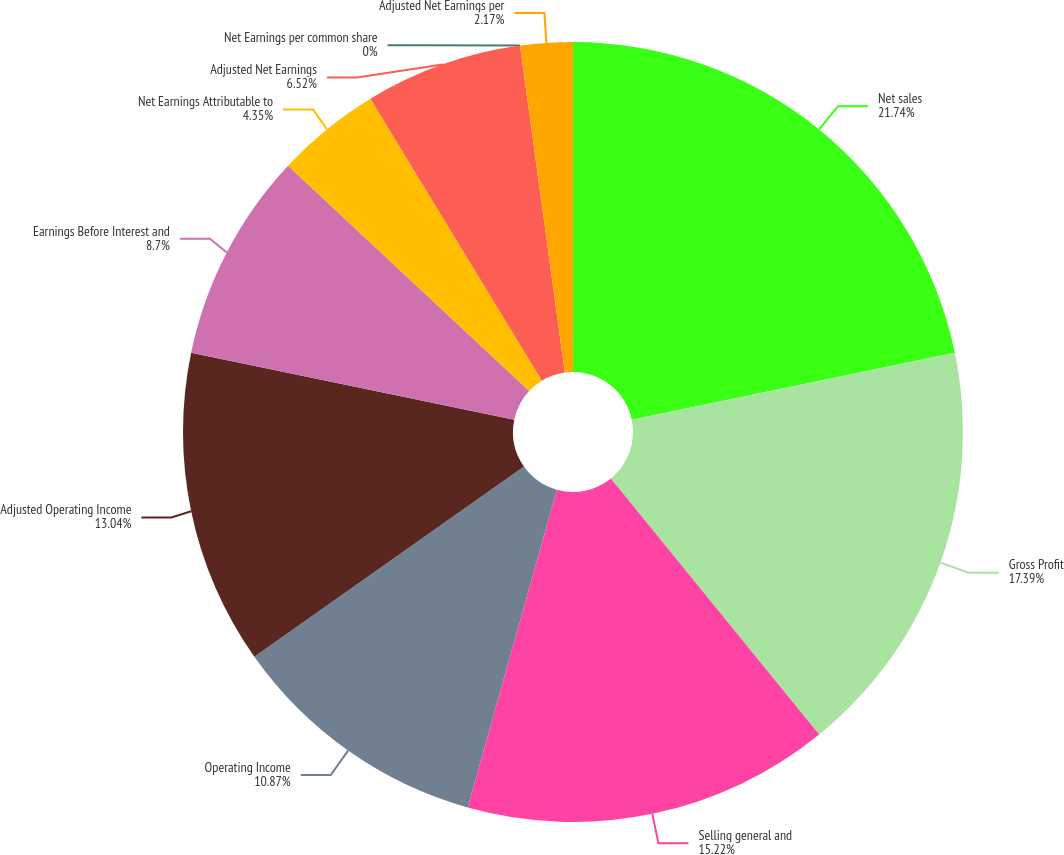<chart> <loc_0><loc_0><loc_500><loc_500><pie_chart><fcel>Net sales<fcel>Gross Profit<fcel>Selling general and<fcel>Operating Income<fcel>Adjusted Operating Income<fcel>Earnings Before Interest and<fcel>Net Earnings Attributable to<fcel>Adjusted Net Earnings<fcel>Net Earnings per common share<fcel>Adjusted Net Earnings per<nl><fcel>21.74%<fcel>17.39%<fcel>15.22%<fcel>10.87%<fcel>13.04%<fcel>8.7%<fcel>4.35%<fcel>6.52%<fcel>0.0%<fcel>2.17%<nl></chart> 